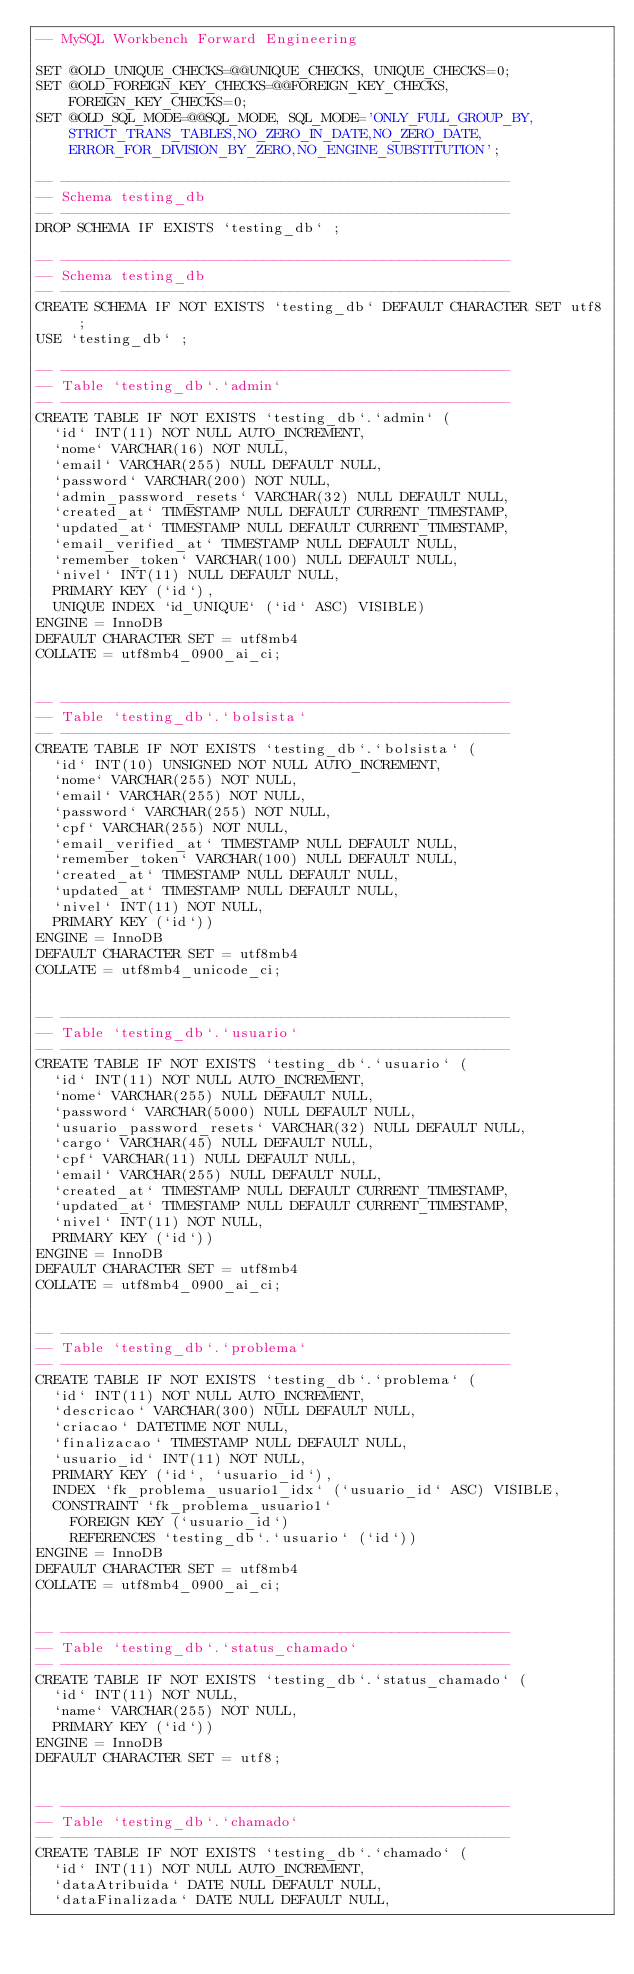<code> <loc_0><loc_0><loc_500><loc_500><_SQL_>-- MySQL Workbench Forward Engineering

SET @OLD_UNIQUE_CHECKS=@@UNIQUE_CHECKS, UNIQUE_CHECKS=0;
SET @OLD_FOREIGN_KEY_CHECKS=@@FOREIGN_KEY_CHECKS, FOREIGN_KEY_CHECKS=0;
SET @OLD_SQL_MODE=@@SQL_MODE, SQL_MODE='ONLY_FULL_GROUP_BY,STRICT_TRANS_TABLES,NO_ZERO_IN_DATE,NO_ZERO_DATE,ERROR_FOR_DIVISION_BY_ZERO,NO_ENGINE_SUBSTITUTION';

-- -----------------------------------------------------
-- Schema testing_db
-- -----------------------------------------------------
DROP SCHEMA IF EXISTS `testing_db` ;

-- -----------------------------------------------------
-- Schema testing_db
-- -----------------------------------------------------
CREATE SCHEMA IF NOT EXISTS `testing_db` DEFAULT CHARACTER SET utf8 ;
USE `testing_db` ;

-- -----------------------------------------------------
-- Table `testing_db`.`admin`
-- -----------------------------------------------------
CREATE TABLE IF NOT EXISTS `testing_db`.`admin` (
  `id` INT(11) NOT NULL AUTO_INCREMENT,
  `nome` VARCHAR(16) NOT NULL,
  `email` VARCHAR(255) NULL DEFAULT NULL,
  `password` VARCHAR(200) NOT NULL,
  `admin_password_resets` VARCHAR(32) NULL DEFAULT NULL,
  `created_at` TIMESTAMP NULL DEFAULT CURRENT_TIMESTAMP,
  `updated_at` TIMESTAMP NULL DEFAULT CURRENT_TIMESTAMP,
  `email_verified_at` TIMESTAMP NULL DEFAULT NULL,
  `remember_token` VARCHAR(100) NULL DEFAULT NULL,
  `nivel` INT(11) NULL DEFAULT NULL,
  PRIMARY KEY (`id`),
  UNIQUE INDEX `id_UNIQUE` (`id` ASC) VISIBLE)
ENGINE = InnoDB
DEFAULT CHARACTER SET = utf8mb4
COLLATE = utf8mb4_0900_ai_ci;


-- -----------------------------------------------------
-- Table `testing_db`.`bolsista`
-- -----------------------------------------------------
CREATE TABLE IF NOT EXISTS `testing_db`.`bolsista` (
  `id` INT(10) UNSIGNED NOT NULL AUTO_INCREMENT,
  `nome` VARCHAR(255) NOT NULL,
  `email` VARCHAR(255) NOT NULL,
  `password` VARCHAR(255) NOT NULL,
  `cpf` VARCHAR(255) NOT NULL,
  `email_verified_at` TIMESTAMP NULL DEFAULT NULL,
  `remember_token` VARCHAR(100) NULL DEFAULT NULL,
  `created_at` TIMESTAMP NULL DEFAULT NULL,
  `updated_at` TIMESTAMP NULL DEFAULT NULL,
  `nivel` INT(11) NOT NULL,
  PRIMARY KEY (`id`))
ENGINE = InnoDB
DEFAULT CHARACTER SET = utf8mb4
COLLATE = utf8mb4_unicode_ci;


-- -----------------------------------------------------
-- Table `testing_db`.`usuario`
-- -----------------------------------------------------
CREATE TABLE IF NOT EXISTS `testing_db`.`usuario` (
  `id` INT(11) NOT NULL AUTO_INCREMENT,
  `nome` VARCHAR(255) NULL DEFAULT NULL,
  `password` VARCHAR(5000) NULL DEFAULT NULL,
  `usuario_password_resets` VARCHAR(32) NULL DEFAULT NULL,
  `cargo` VARCHAR(45) NULL DEFAULT NULL,
  `cpf` VARCHAR(11) NULL DEFAULT NULL,
  `email` VARCHAR(255) NULL DEFAULT NULL,
  `created_at` TIMESTAMP NULL DEFAULT CURRENT_TIMESTAMP,
  `updated_at` TIMESTAMP NULL DEFAULT CURRENT_TIMESTAMP,
  `nivel` INT(11) NOT NULL,
  PRIMARY KEY (`id`))
ENGINE = InnoDB
DEFAULT CHARACTER SET = utf8mb4
COLLATE = utf8mb4_0900_ai_ci;


-- -----------------------------------------------------
-- Table `testing_db`.`problema`
-- -----------------------------------------------------
CREATE TABLE IF NOT EXISTS `testing_db`.`problema` (
  `id` INT(11) NOT NULL AUTO_INCREMENT,
  `descricao` VARCHAR(300) NULL DEFAULT NULL,
  `criacao` DATETIME NOT NULL,
  `finalizacao` TIMESTAMP NULL DEFAULT NULL,
  `usuario_id` INT(11) NOT NULL,
  PRIMARY KEY (`id`, `usuario_id`),
  INDEX `fk_problema_usuario1_idx` (`usuario_id` ASC) VISIBLE,
  CONSTRAINT `fk_problema_usuario1`
    FOREIGN KEY (`usuario_id`)
    REFERENCES `testing_db`.`usuario` (`id`))
ENGINE = InnoDB
DEFAULT CHARACTER SET = utf8mb4
COLLATE = utf8mb4_0900_ai_ci;


-- -----------------------------------------------------
-- Table `testing_db`.`status_chamado`
-- -----------------------------------------------------
CREATE TABLE IF NOT EXISTS `testing_db`.`status_chamado` (
  `id` INT(11) NOT NULL,
  `name` VARCHAR(255) NOT NULL,
  PRIMARY KEY (`id`))
ENGINE = InnoDB
DEFAULT CHARACTER SET = utf8;


-- -----------------------------------------------------
-- Table `testing_db`.`chamado`
-- -----------------------------------------------------
CREATE TABLE IF NOT EXISTS `testing_db`.`chamado` (
  `id` INT(11) NOT NULL AUTO_INCREMENT,
  `dataAtribuida` DATE NULL DEFAULT NULL,
  `dataFinalizada` DATE NULL DEFAULT NULL,</code> 